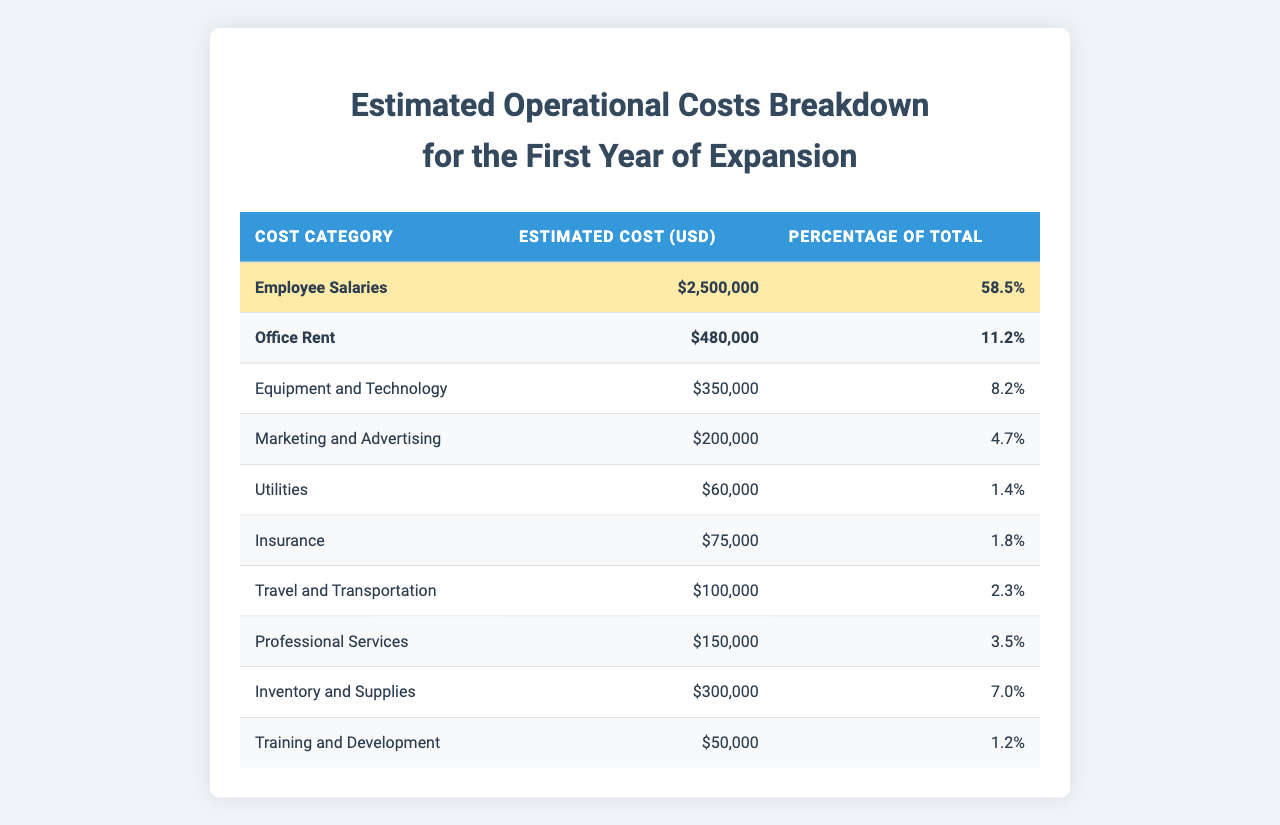What is the estimated cost of Employee Salaries? From the table, the estimated cost for Employee Salaries is listed under the relevant row. It shows $2,500,000.
Answer: $2,500,000 What percentage of the total costs does Office Rent represent? Referring to the table, the percentage for Office Rent is shown as 11.2%.
Answer: 11.2% Which cost category has the lowest estimated cost? By scanning the table, the lowest estimated cost is in Training and Development, which is $50,000.
Answer: $50,000 What is the total estimated cost for Marketing and Advertising and Professional Services combined? Adding the estimated costs for Marketing and Advertising ($200,000) and Professional Services ($150,000) gives a total of $350,000.
Answer: $350,000 Is the estimated cost for Utilities higher than that for Insurance? The table shows Utilities at $60,000 and Insurance at $75,000. Since $60,000 is not higher than $75,000, the answer is no.
Answer: No What is the total estimated cost for all categories? To find the total, sum up all estimated costs: $2,500,000 + $480,000 + $350,000 + $200,000 + $60,000 + $75,000 + $100,000 + $150,000 + $300,000 + $50,000, which equals $4,865,000.
Answer: $4,865,000 What percentage of the total cost does Inventory and Supplies take? The table shows the estimated cost for Inventory and Supplies as $300,000 and a percentage of 7.0%. This information is directly provided.
Answer: 7.0% What is the combined estimated cost for the top three highest cost categories? The top three categories are Employee Salaries ($2,500,000), Office Rent ($480,000), and Equipment and Technology ($350,000). Their sum is $2,500,000 + $480,000 + $350,000 = $3,330,000.
Answer: $3,330,000 Are the combined costs of Utilities, Insurance, and Travel and Transportation more than $200,000? The costs are Utilities ($60,000), Insurance ($75,000), and Travel and Transportation ($100,000). Their total is $60,000 + $75,000 + $100,000 = $235,000, which is greater than $200,000.
Answer: Yes What is the average estimated cost across all categories? To find the average, add up all estimated costs ($4,865,000) and divide by the number of categories (10). This gives $4,865,000 / 10 = $486,500.
Answer: $486,500 